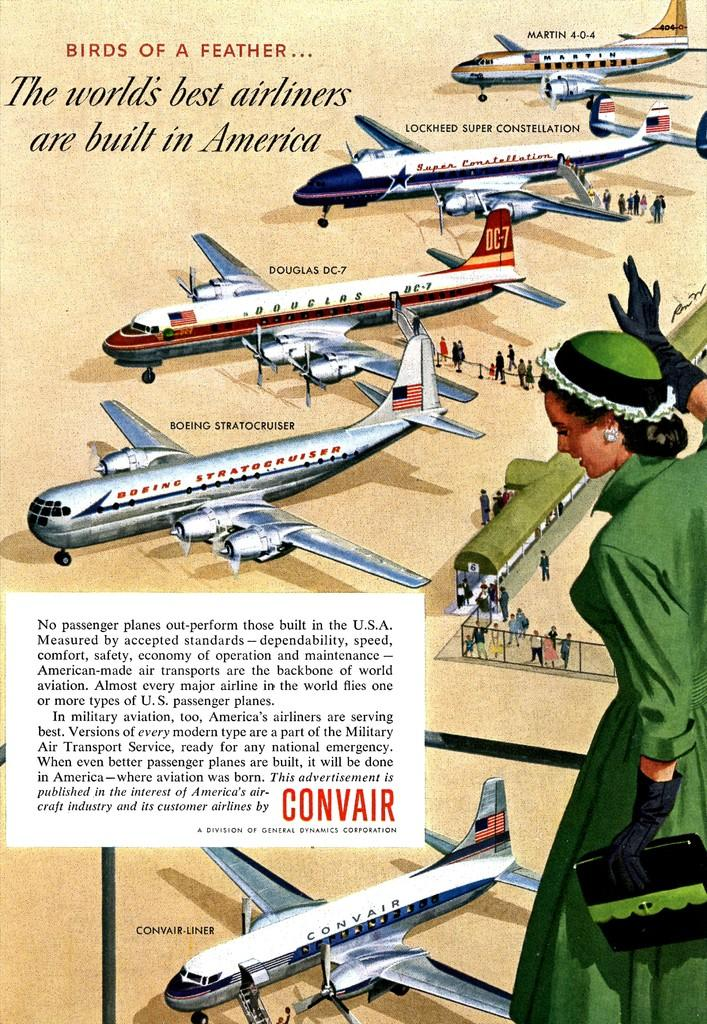<image>
Render a clear and concise summary of the photo. A poster of a lady and airplanes that are called birds of a feather. 